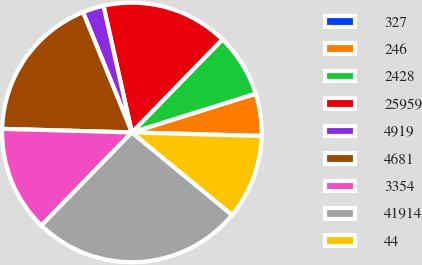Convert chart. <chart><loc_0><loc_0><loc_500><loc_500><pie_chart><fcel>327<fcel>246<fcel>2428<fcel>25959<fcel>4919<fcel>4681<fcel>3354<fcel>41914<fcel>44<nl><fcel>0.0%<fcel>5.26%<fcel>7.89%<fcel>15.79%<fcel>2.63%<fcel>18.42%<fcel>13.16%<fcel>26.31%<fcel>10.53%<nl></chart> 